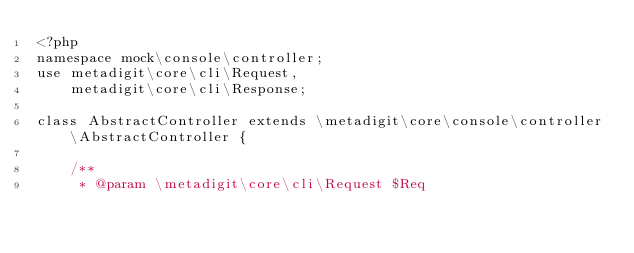Convert code to text. <code><loc_0><loc_0><loc_500><loc_500><_PHP_><?php
namespace mock\console\controller;
use metadigit\core\cli\Request,
	metadigit\core\cli\Response;

class AbstractController extends \metadigit\core\console\controller\AbstractController {

	/**
	 * @param \metadigit\core\cli\Request $Req</code> 